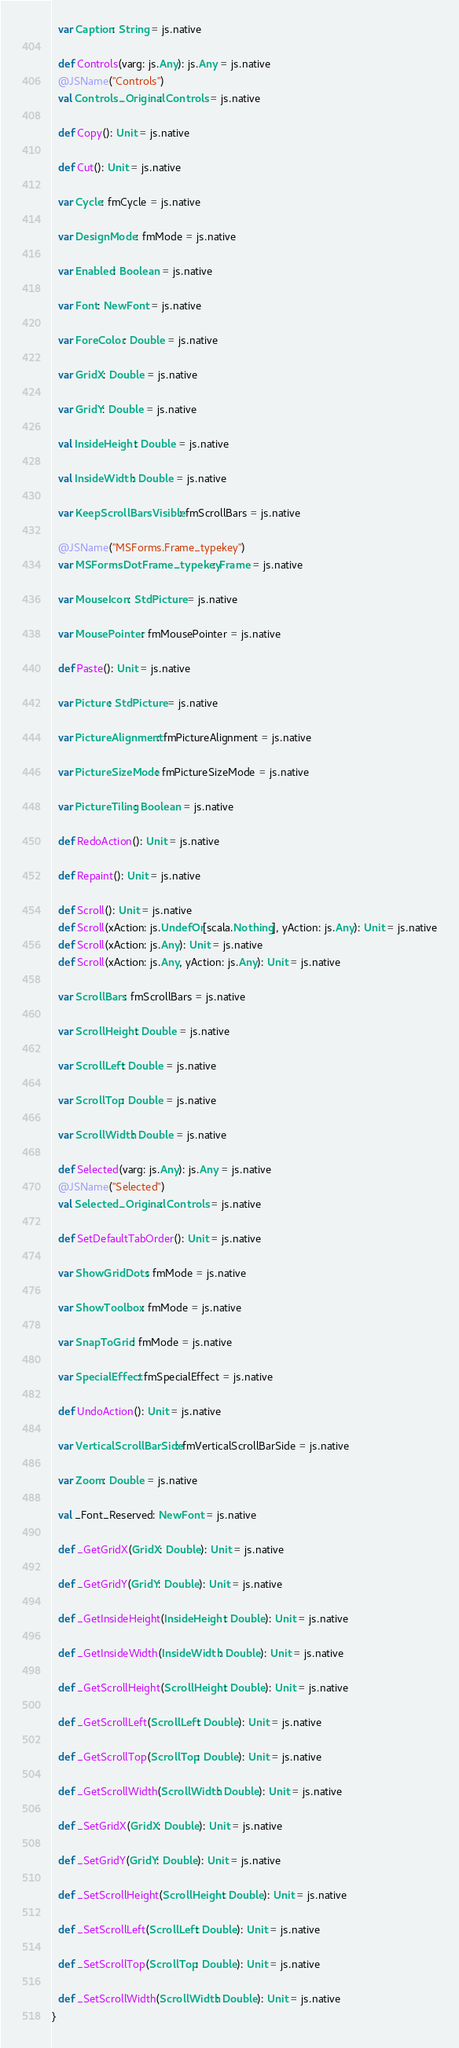<code> <loc_0><loc_0><loc_500><loc_500><_Scala_>  var Caption: String = js.native
  
  def Controls(varg: js.Any): js.Any = js.native
  @JSName("Controls")
  val Controls_Original: Controls = js.native
  
  def Copy(): Unit = js.native
  
  def Cut(): Unit = js.native
  
  var Cycle: fmCycle = js.native
  
  var DesignMode: fmMode = js.native
  
  var Enabled: Boolean = js.native
  
  var Font: NewFont = js.native
  
  var ForeColor: Double = js.native
  
  var GridX: Double = js.native
  
  var GridY: Double = js.native
  
  val InsideHeight: Double = js.native
  
  val InsideWidth: Double = js.native
  
  var KeepScrollBarsVisible: fmScrollBars = js.native
  
  @JSName("MSForms.Frame_typekey")
  var MSFormsDotFrame_typekey: Frame = js.native
  
  var MouseIcon: StdPicture = js.native
  
  var MousePointer: fmMousePointer = js.native
  
  def Paste(): Unit = js.native
  
  var Picture: StdPicture = js.native
  
  var PictureAlignment: fmPictureAlignment = js.native
  
  var PictureSizeMode: fmPictureSizeMode = js.native
  
  var PictureTiling: Boolean = js.native
  
  def RedoAction(): Unit = js.native
  
  def Repaint(): Unit = js.native
  
  def Scroll(): Unit = js.native
  def Scroll(xAction: js.UndefOr[scala.Nothing], yAction: js.Any): Unit = js.native
  def Scroll(xAction: js.Any): Unit = js.native
  def Scroll(xAction: js.Any, yAction: js.Any): Unit = js.native
  
  var ScrollBars: fmScrollBars = js.native
  
  var ScrollHeight: Double = js.native
  
  var ScrollLeft: Double = js.native
  
  var ScrollTop: Double = js.native
  
  var ScrollWidth: Double = js.native
  
  def Selected(varg: js.Any): js.Any = js.native
  @JSName("Selected")
  val Selected_Original: Controls = js.native
  
  def SetDefaultTabOrder(): Unit = js.native
  
  var ShowGridDots: fmMode = js.native
  
  var ShowToolbox: fmMode = js.native
  
  var SnapToGrid: fmMode = js.native
  
  var SpecialEffect: fmSpecialEffect = js.native
  
  def UndoAction(): Unit = js.native
  
  var VerticalScrollBarSide: fmVerticalScrollBarSide = js.native
  
  var Zoom: Double = js.native
  
  val _Font_Reserved: NewFont = js.native
  
  def _GetGridX(GridX: Double): Unit = js.native
  
  def _GetGridY(GridY: Double): Unit = js.native
  
  def _GetInsideHeight(InsideHeight: Double): Unit = js.native
  
  def _GetInsideWidth(InsideWidth: Double): Unit = js.native
  
  def _GetScrollHeight(ScrollHeight: Double): Unit = js.native
  
  def _GetScrollLeft(ScrollLeft: Double): Unit = js.native
  
  def _GetScrollTop(ScrollTop: Double): Unit = js.native
  
  def _GetScrollWidth(ScrollWidth: Double): Unit = js.native
  
  def _SetGridX(GridX: Double): Unit = js.native
  
  def _SetGridY(GridY: Double): Unit = js.native
  
  def _SetScrollHeight(ScrollHeight: Double): Unit = js.native
  
  def _SetScrollLeft(ScrollLeft: Double): Unit = js.native
  
  def _SetScrollTop(ScrollTop: Double): Unit = js.native
  
  def _SetScrollWidth(ScrollWidth: Double): Unit = js.native
}
</code> 